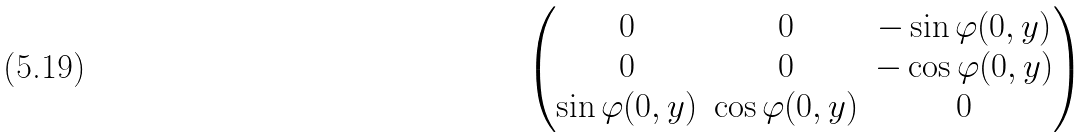Convert formula to latex. <formula><loc_0><loc_0><loc_500><loc_500>\begin{pmatrix} 0 & 0 & - \sin { \varphi ( 0 , y ) } \\ 0 & 0 & - \cos { \varphi ( 0 , y ) } \\ \sin { \varphi ( 0 , y ) } & \cos { \varphi ( 0 , y ) } & 0 \end{pmatrix}</formula> 